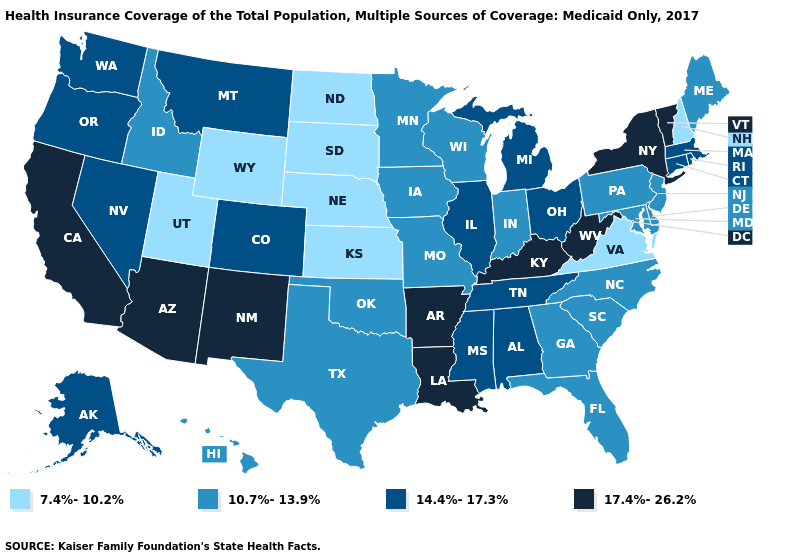Name the states that have a value in the range 17.4%-26.2%?
Write a very short answer. Arizona, Arkansas, California, Kentucky, Louisiana, New Mexico, New York, Vermont, West Virginia. What is the value of Nevada?
Concise answer only. 14.4%-17.3%. Name the states that have a value in the range 14.4%-17.3%?
Keep it brief. Alabama, Alaska, Colorado, Connecticut, Illinois, Massachusetts, Michigan, Mississippi, Montana, Nevada, Ohio, Oregon, Rhode Island, Tennessee, Washington. What is the highest value in states that border Minnesota?
Quick response, please. 10.7%-13.9%. Name the states that have a value in the range 7.4%-10.2%?
Give a very brief answer. Kansas, Nebraska, New Hampshire, North Dakota, South Dakota, Utah, Virginia, Wyoming. Does Texas have the lowest value in the South?
Keep it brief. No. Which states have the lowest value in the USA?
Short answer required. Kansas, Nebraska, New Hampshire, North Dakota, South Dakota, Utah, Virginia, Wyoming. Does Ohio have the lowest value in the USA?
Be succinct. No. Name the states that have a value in the range 14.4%-17.3%?
Give a very brief answer. Alabama, Alaska, Colorado, Connecticut, Illinois, Massachusetts, Michigan, Mississippi, Montana, Nevada, Ohio, Oregon, Rhode Island, Tennessee, Washington. What is the value of Iowa?
Be succinct. 10.7%-13.9%. Name the states that have a value in the range 17.4%-26.2%?
Give a very brief answer. Arizona, Arkansas, California, Kentucky, Louisiana, New Mexico, New York, Vermont, West Virginia. What is the lowest value in the USA?
Short answer required. 7.4%-10.2%. What is the highest value in states that border Minnesota?
Short answer required. 10.7%-13.9%. Which states have the highest value in the USA?
Short answer required. Arizona, Arkansas, California, Kentucky, Louisiana, New Mexico, New York, Vermont, West Virginia. Among the states that border Wyoming , which have the lowest value?
Quick response, please. Nebraska, South Dakota, Utah. 